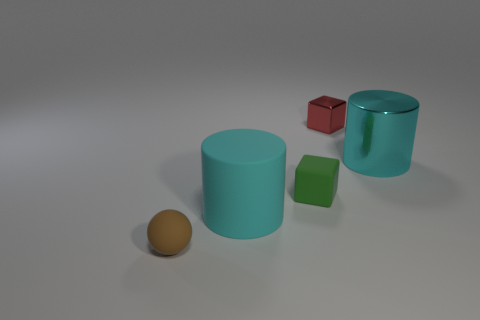What number of cylinders are in front of the green rubber cube?
Provide a succinct answer. 1. There is a large object that is made of the same material as the tiny green cube; what color is it?
Your answer should be very brief. Cyan. There is a green object; is it the same size as the object in front of the big cyan matte cylinder?
Keep it short and to the point. Yes. What size is the object to the left of the big thing that is in front of the tiny rubber object that is right of the tiny brown thing?
Provide a short and direct response. Small. How many matte objects are either small red things or small things?
Your response must be concise. 2. What is the color of the small rubber object behind the brown matte sphere?
Offer a very short reply. Green. There is a cyan object that is the same size as the metallic cylinder; what shape is it?
Your answer should be compact. Cylinder. Does the rubber block have the same color as the cylinder that is behind the big rubber cylinder?
Your answer should be very brief. No. How many objects are either tiny matte objects behind the tiny brown matte thing or objects that are to the right of the small rubber block?
Make the answer very short. 3. There is a green thing that is the same size as the brown object; what is its material?
Provide a short and direct response. Rubber. 